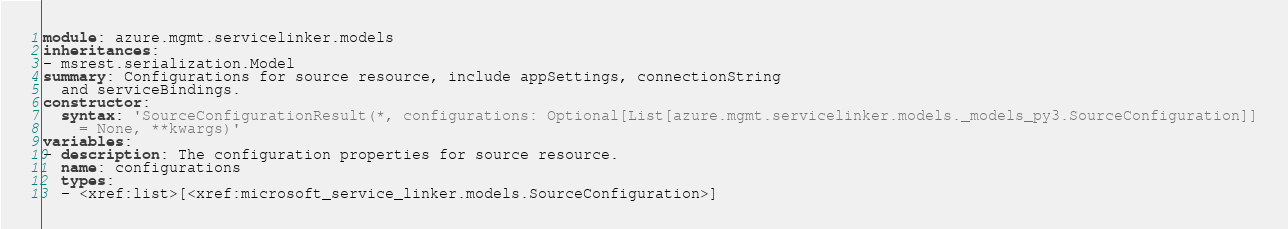<code> <loc_0><loc_0><loc_500><loc_500><_YAML_>module: azure.mgmt.servicelinker.models
inheritances:
- msrest.serialization.Model
summary: Configurations for source resource, include appSettings, connectionString
  and serviceBindings.
constructor:
  syntax: 'SourceConfigurationResult(*, configurations: Optional[List[azure.mgmt.servicelinker.models._models_py3.SourceConfiguration]]
    = None, **kwargs)'
variables:
- description: The configuration properties for source resource.
  name: configurations
  types:
  - <xref:list>[<xref:microsoft_service_linker.models.SourceConfiguration>]
</code> 